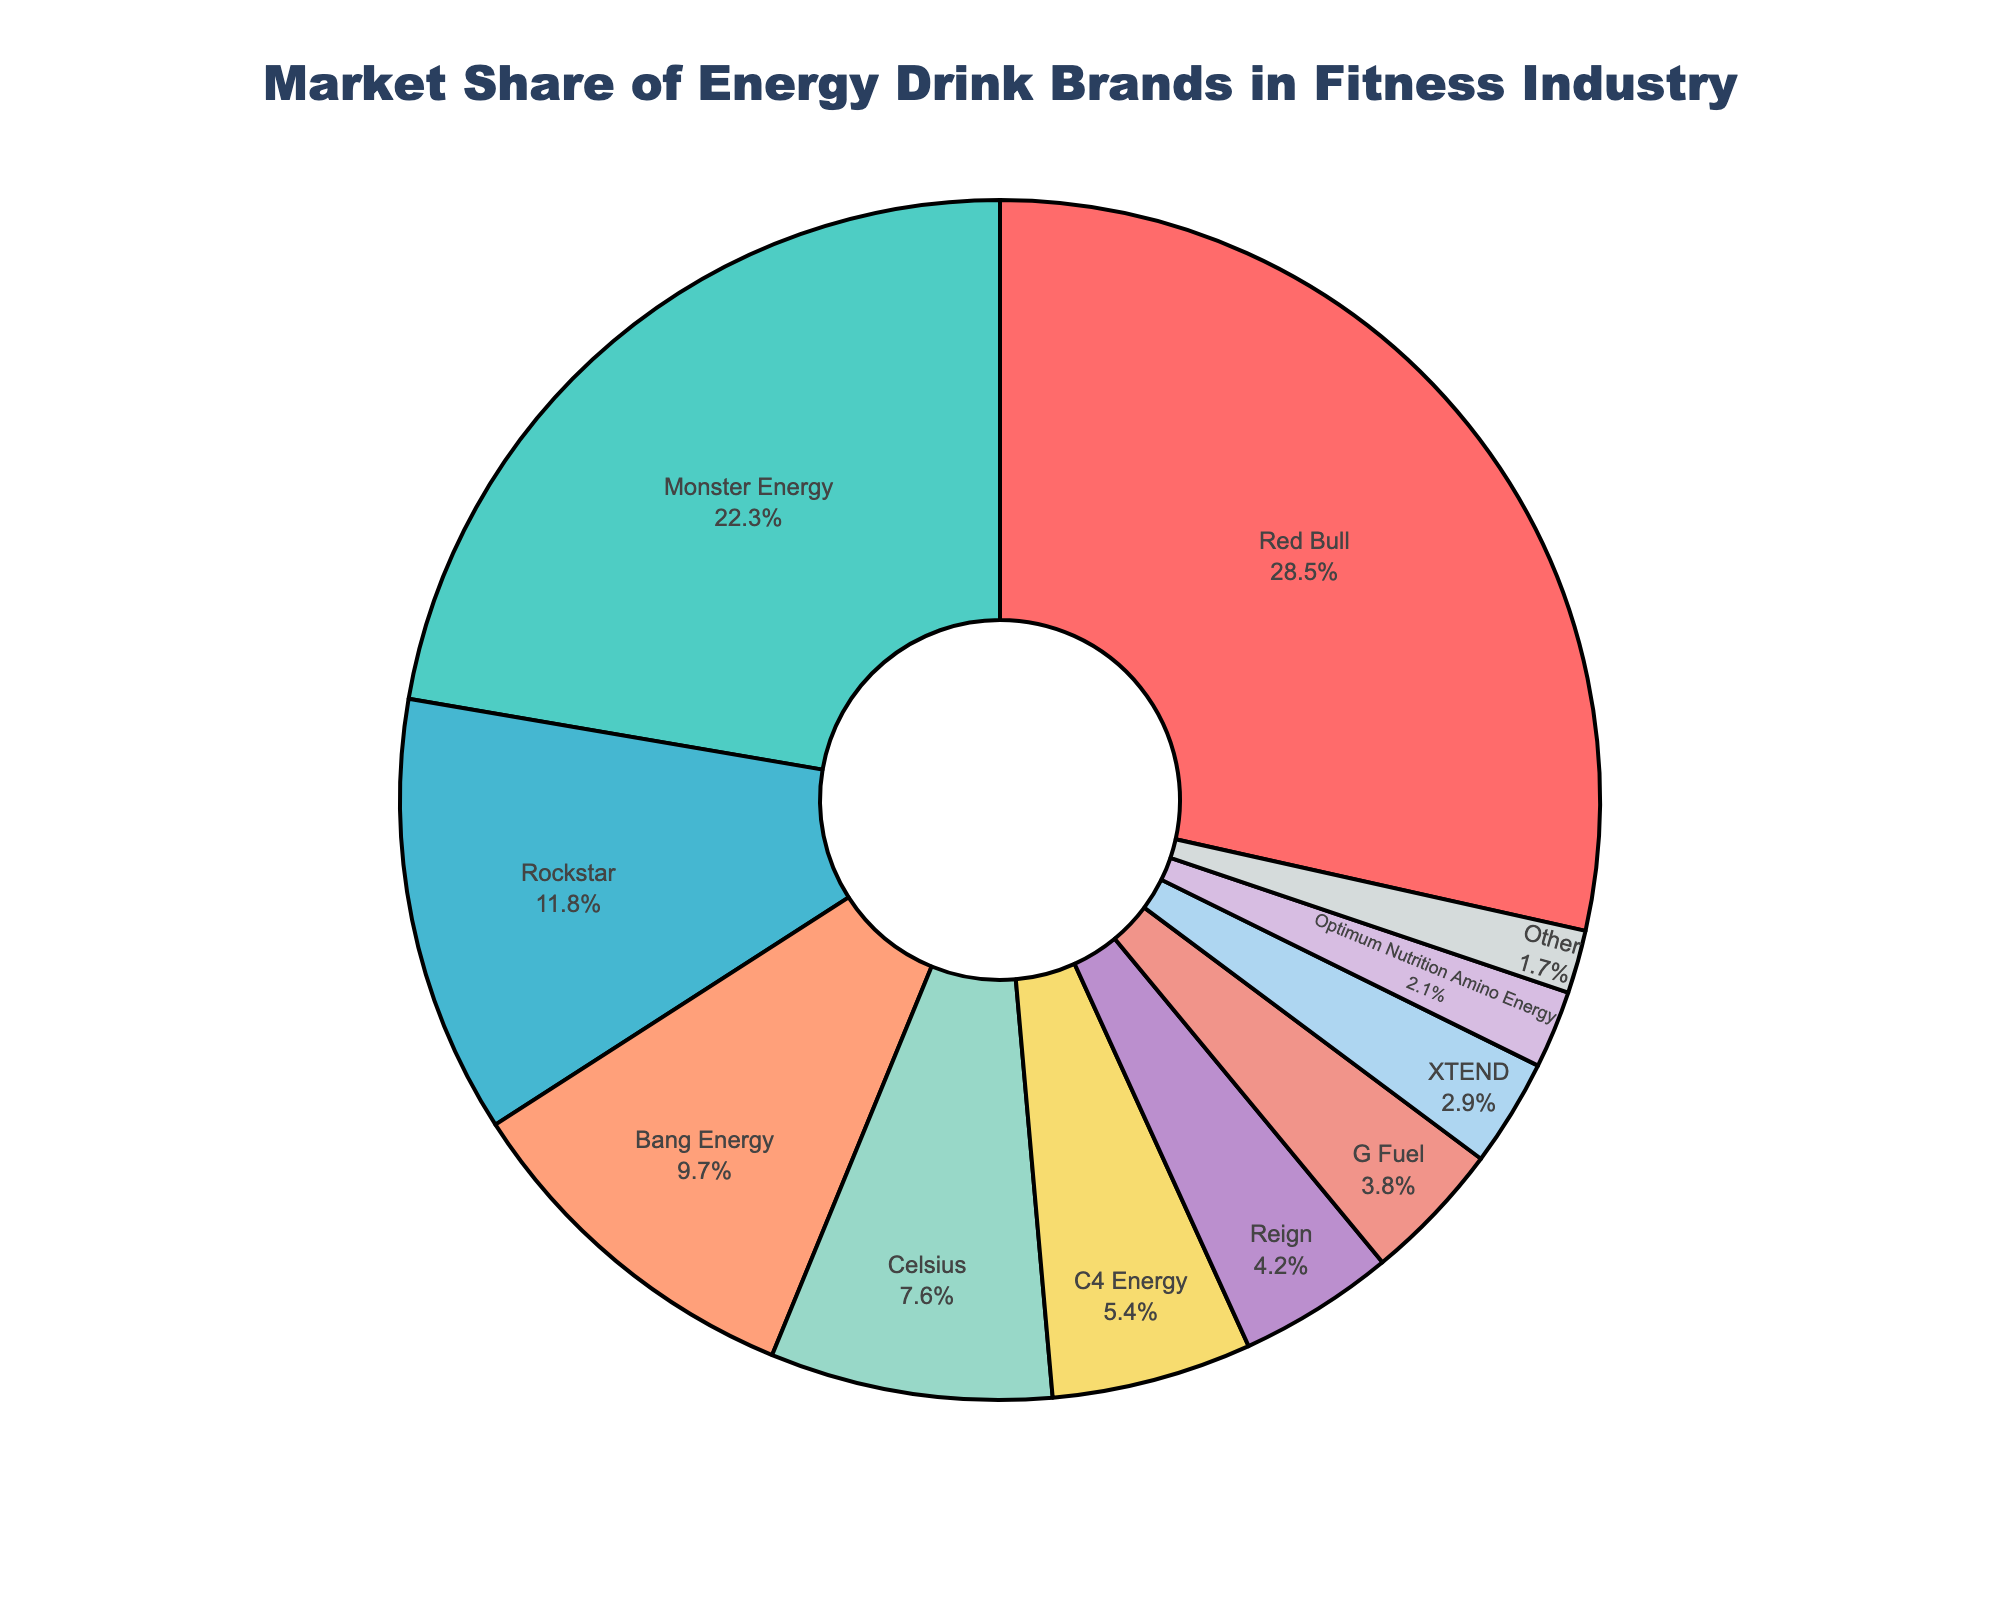Which brand has the largest market share? Red Bull has the largest market share as indicated by its slice being the biggest in the pie chart.
Answer: Red Bull Which two brands together make up just over half of the market share? Red Bull's share is 28.5% and Monster Energy's share is 22.3%. Summing these gives 28.5% + 22.3% = 50.8%.
Answer: Red Bull and Monster Energy How much more market share does Red Bull have compared to Bang Energy? Red Bull's market share is 28.5% and Bang Energy's is 9.7%. The difference is 28.5% - 9.7% = 18.8%.
Answer: 18.8% What is the combined market share of brands with less than 5% each? The brands with less than 5% are Reign (4.2%), G Fuel (3.8%), XTEND (2.9%), Optimum Nutrition Amino Energy (2.1%), and Other (1.7%). Summing these gives 4.2% + 3.8% + 2.9% + 2.1% + 1.7% = 14.7%.
Answer: 14.7% Which brand has the second smallest market share and what is it? Optimum Nutrition Amino Energy has the second smallest market share of 2.1%, as indicated by its small slice but being slightly larger than "Other" which is 1.7%.
Answer: Optimum Nutrition Amino Energy with 2.1% How many brands have a market share greater than 10%? The brands with more than 10% market share are Red Bull (28.5%), Monster Energy (22.3%), and Rockstar (11.8%). This makes three brands.
Answer: 3 What is the average market share of the top four brands? The top four brands are Red Bull (28.5%), Monster Energy (22.3%), Rockstar (11.8%), and Bang Energy (9.7%). The sum is 28.5% + 22.3% + 11.8% + 9.7% = 72.3%. The average is 72.3% / 4 = 18.075%.
Answer: 18.075% Which brand is represented by the green color and what is its market share? The green-colored slice represents Monster Energy, which has a market share of 22.3%.
Answer: Monster Energy with 22.3% What is the total market share of Celsius, C4 Energy, and Reign combined? Celsius has 7.6%, C4 Energy has 5.4%, and Reign has 4.2%. Summing these gives 7.6% + 5.4% + 4.2% = 17.2%.
Answer: 17.2% Is the market share of Reign greater than the combined market share of XTEND and Optimum Nutrition Amino Energy? Reign's share is 4.2%. XTEND's share is 2.9% and Optimum Nutrition Amino Energy's share is 2.1%. Combined, XTEND and Optimum Nutrition Amino Energy have 2.9% + 2.1% = 5%. 4.2% < 5%, thus Reign's share is not greater.
Answer: No 